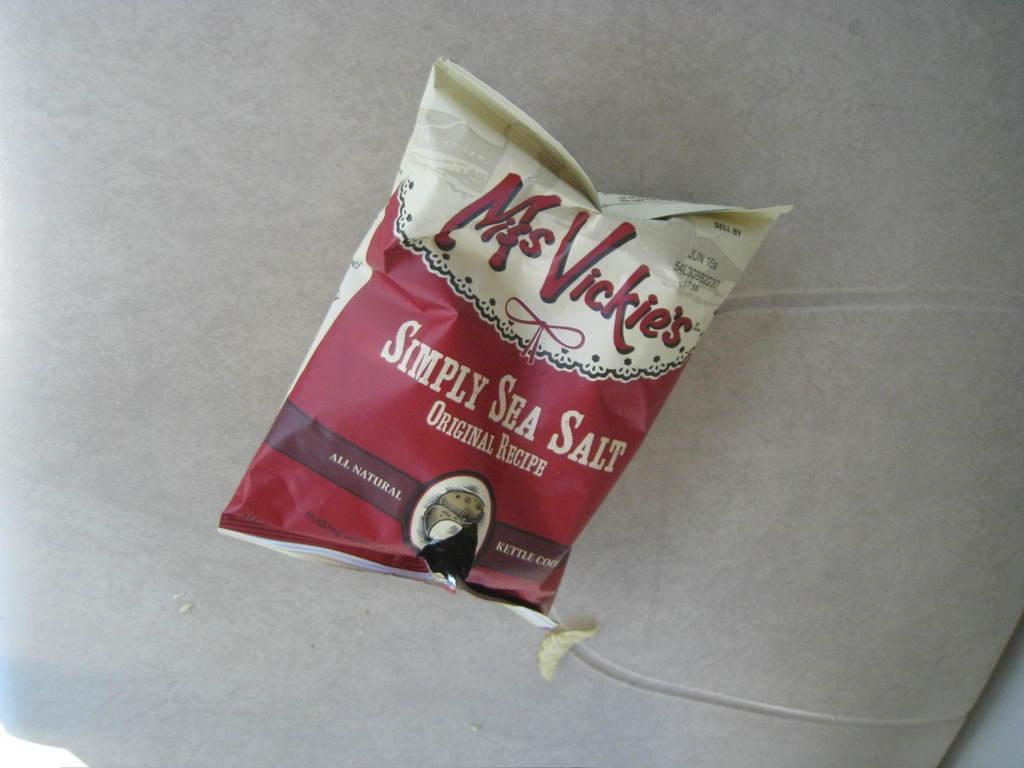Please provide a concise description of this image. In this image there is a chips packet in the middle. 